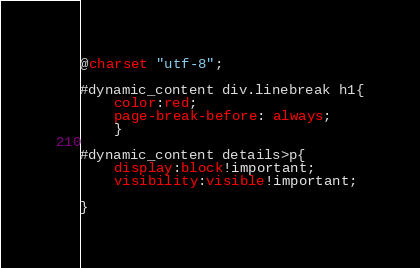Convert code to text. <code><loc_0><loc_0><loc_500><loc_500><_CSS_>@charset "utf-8";

#dynamic_content div.linebreak h1{
	color:red;
	page-break-before: always;
	}

#dynamic_content details>p{
	display:block!important;
	visibility:visible!important;

}</code> 